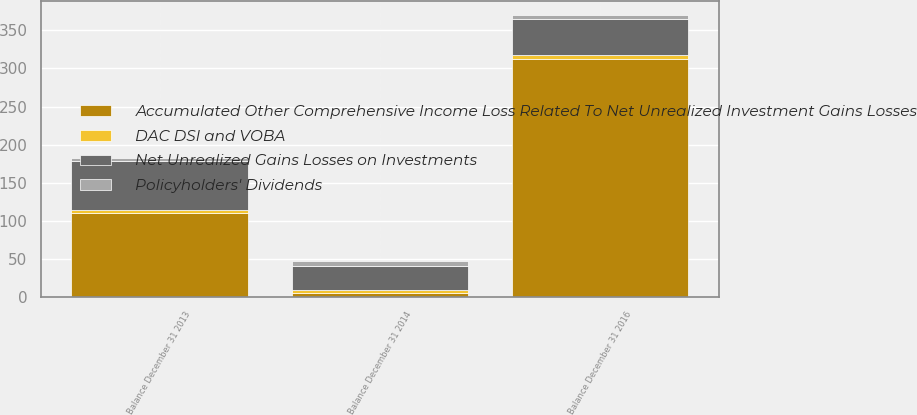Convert chart to OTSL. <chart><loc_0><loc_0><loc_500><loc_500><stacked_bar_chart><ecel><fcel>Balance December 31 2013<fcel>Balance December 31 2014<fcel>Balance December 31 2016<nl><fcel>Accumulated Other Comprehensive Income Loss Related To Net Unrealized Investment Gains Losses<fcel>110<fcel>6<fcel>312<nl><fcel>Policyholders' Dividends<fcel>5<fcel>6<fcel>5<nl><fcel>DAC DSI and VOBA<fcel>4<fcel>3<fcel>6<nl><fcel>Net Unrealized Gains Losses on Investments<fcel>64<fcel>32<fcel>47<nl></chart> 